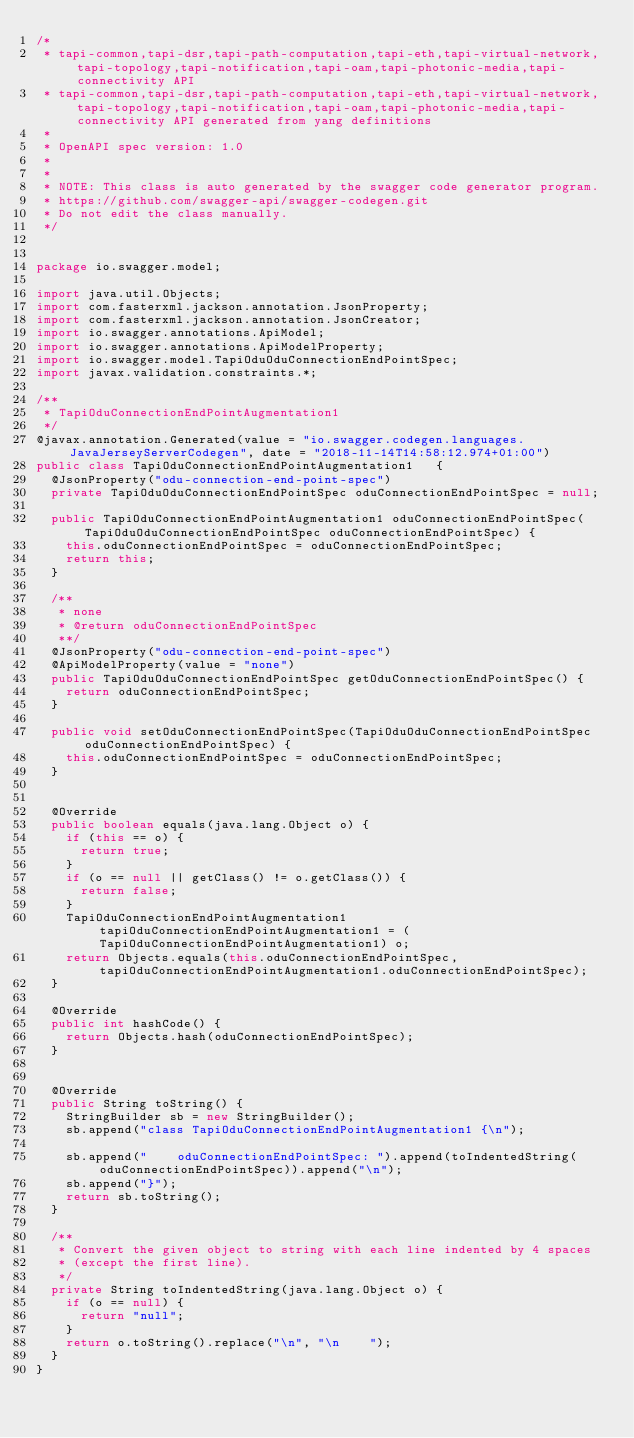Convert code to text. <code><loc_0><loc_0><loc_500><loc_500><_Java_>/*
 * tapi-common,tapi-dsr,tapi-path-computation,tapi-eth,tapi-virtual-network,tapi-topology,tapi-notification,tapi-oam,tapi-photonic-media,tapi-connectivity API
 * tapi-common,tapi-dsr,tapi-path-computation,tapi-eth,tapi-virtual-network,tapi-topology,tapi-notification,tapi-oam,tapi-photonic-media,tapi-connectivity API generated from yang definitions
 *
 * OpenAPI spec version: 1.0
 * 
 *
 * NOTE: This class is auto generated by the swagger code generator program.
 * https://github.com/swagger-api/swagger-codegen.git
 * Do not edit the class manually.
 */


package io.swagger.model;

import java.util.Objects;
import com.fasterxml.jackson.annotation.JsonProperty;
import com.fasterxml.jackson.annotation.JsonCreator;
import io.swagger.annotations.ApiModel;
import io.swagger.annotations.ApiModelProperty;
import io.swagger.model.TapiOduOduConnectionEndPointSpec;
import javax.validation.constraints.*;

/**
 * TapiOduConnectionEndPointAugmentation1
 */
@javax.annotation.Generated(value = "io.swagger.codegen.languages.JavaJerseyServerCodegen", date = "2018-11-14T14:58:12.974+01:00")
public class TapiOduConnectionEndPointAugmentation1   {
  @JsonProperty("odu-connection-end-point-spec")
  private TapiOduOduConnectionEndPointSpec oduConnectionEndPointSpec = null;

  public TapiOduConnectionEndPointAugmentation1 oduConnectionEndPointSpec(TapiOduOduConnectionEndPointSpec oduConnectionEndPointSpec) {
    this.oduConnectionEndPointSpec = oduConnectionEndPointSpec;
    return this;
  }

  /**
   * none
   * @return oduConnectionEndPointSpec
   **/
  @JsonProperty("odu-connection-end-point-spec")
  @ApiModelProperty(value = "none")
  public TapiOduOduConnectionEndPointSpec getOduConnectionEndPointSpec() {
    return oduConnectionEndPointSpec;
  }

  public void setOduConnectionEndPointSpec(TapiOduOduConnectionEndPointSpec oduConnectionEndPointSpec) {
    this.oduConnectionEndPointSpec = oduConnectionEndPointSpec;
  }


  @Override
  public boolean equals(java.lang.Object o) {
    if (this == o) {
      return true;
    }
    if (o == null || getClass() != o.getClass()) {
      return false;
    }
    TapiOduConnectionEndPointAugmentation1 tapiOduConnectionEndPointAugmentation1 = (TapiOduConnectionEndPointAugmentation1) o;
    return Objects.equals(this.oduConnectionEndPointSpec, tapiOduConnectionEndPointAugmentation1.oduConnectionEndPointSpec);
  }

  @Override
  public int hashCode() {
    return Objects.hash(oduConnectionEndPointSpec);
  }


  @Override
  public String toString() {
    StringBuilder sb = new StringBuilder();
    sb.append("class TapiOduConnectionEndPointAugmentation1 {\n");
    
    sb.append("    oduConnectionEndPointSpec: ").append(toIndentedString(oduConnectionEndPointSpec)).append("\n");
    sb.append("}");
    return sb.toString();
  }

  /**
   * Convert the given object to string with each line indented by 4 spaces
   * (except the first line).
   */
  private String toIndentedString(java.lang.Object o) {
    if (o == null) {
      return "null";
    }
    return o.toString().replace("\n", "\n    ");
  }
}

</code> 